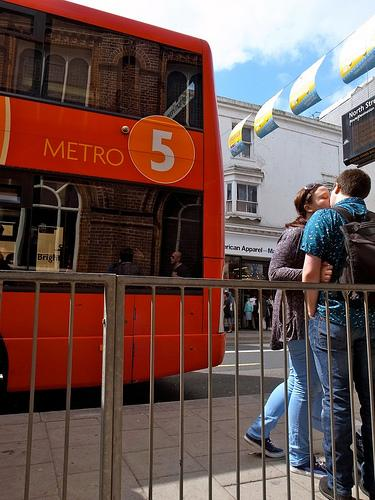Briefly narrate the possible story behind the image of the couple. The couple might be having a romantic moment and sharing a kiss on a sidewalk in a bustling city, with a red bus and an airport sign nearby, indicating they could be on a vacation or a date. Analyze and state the quality of the image based on the object sizes and positions. The image quality appears to be detailed and precise, with numerous objects having clearly defined positions and sizes, allowing for accurate analysis and understanding. How many clouds can be observed in the blue sky, and what are their general sizes? There are several white clouds in the blue sky, with varying sizes. What is unique about the design on the red bus and what does the orange text on the bus read? The unique design on the red bus includes a circular design print and a five-number print, and the orange text on the bus reads "Metro 5." What might be the possible sentiment in the image? The sentiment in the image could be considered romantic or happy, as there is a couple kissing on a sidewalk, and the actions happening around them create a vibrant city atmosphere. 